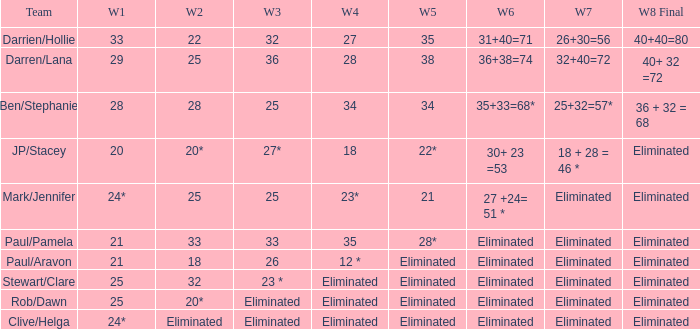Name the week 3 for team of mark/jennifer 25.0. 